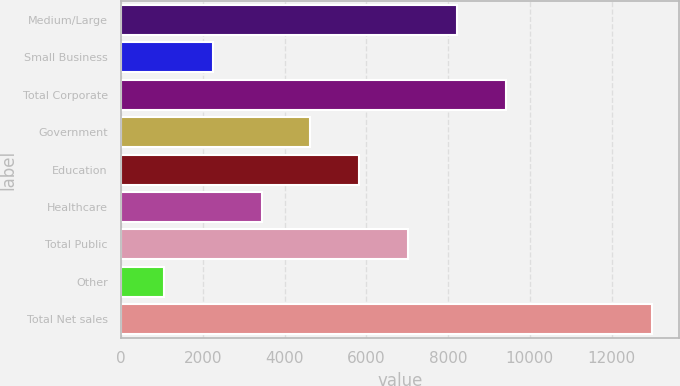<chart> <loc_0><loc_0><loc_500><loc_500><bar_chart><fcel>Medium/Large<fcel>Small Business<fcel>Total Corporate<fcel>Government<fcel>Education<fcel>Healthcare<fcel>Total Public<fcel>Other<fcel>Total Net sales<nl><fcel>8211.94<fcel>2240.99<fcel>9406.13<fcel>4629.37<fcel>5823.56<fcel>3435.18<fcel>7017.75<fcel>1046.8<fcel>12988.7<nl></chart> 